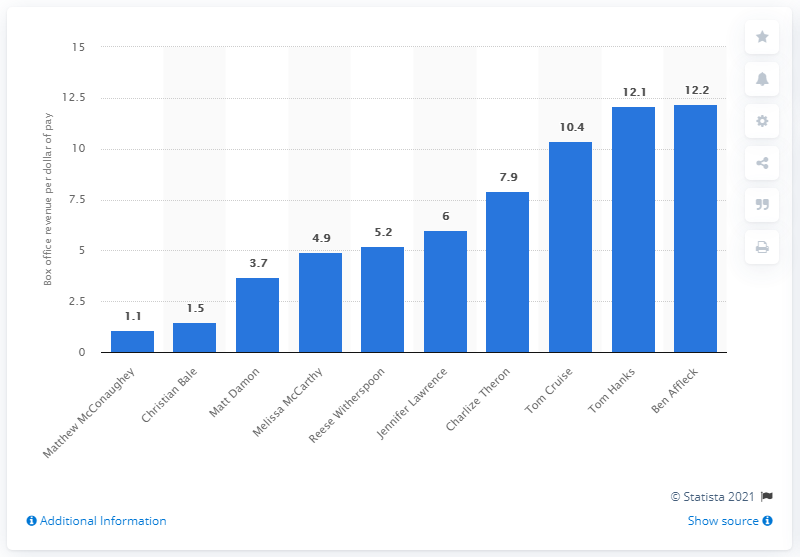What does this graph tell us about the box office efficiency of actors? This graph illustrates the box office return per dollar paid to each listed actor, indicating who brings the most financial value relative to their pay in the film industry. Actors like Ben Affleck and Tom Hanks who top the chart offer the highest returns, demonstrating their profitability and appeal in cinematic projects. Why might some actors have lower returns? Several factors could contribute to lower returns, including the type of movies they participate in (genre, target audience), their marketability during the time of those movies' release, and possibly the overall budget of the films compared to their box office performance. 